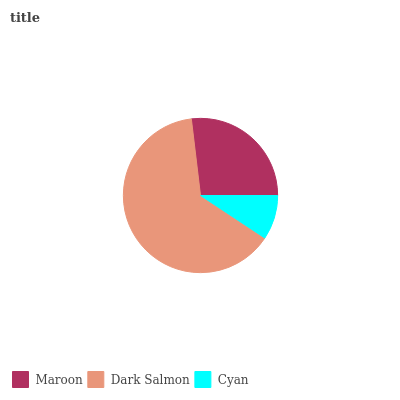Is Cyan the minimum?
Answer yes or no. Yes. Is Dark Salmon the maximum?
Answer yes or no. Yes. Is Dark Salmon the minimum?
Answer yes or no. No. Is Cyan the maximum?
Answer yes or no. No. Is Dark Salmon greater than Cyan?
Answer yes or no. Yes. Is Cyan less than Dark Salmon?
Answer yes or no. Yes. Is Cyan greater than Dark Salmon?
Answer yes or no. No. Is Dark Salmon less than Cyan?
Answer yes or no. No. Is Maroon the high median?
Answer yes or no. Yes. Is Maroon the low median?
Answer yes or no. Yes. Is Cyan the high median?
Answer yes or no. No. Is Cyan the low median?
Answer yes or no. No. 